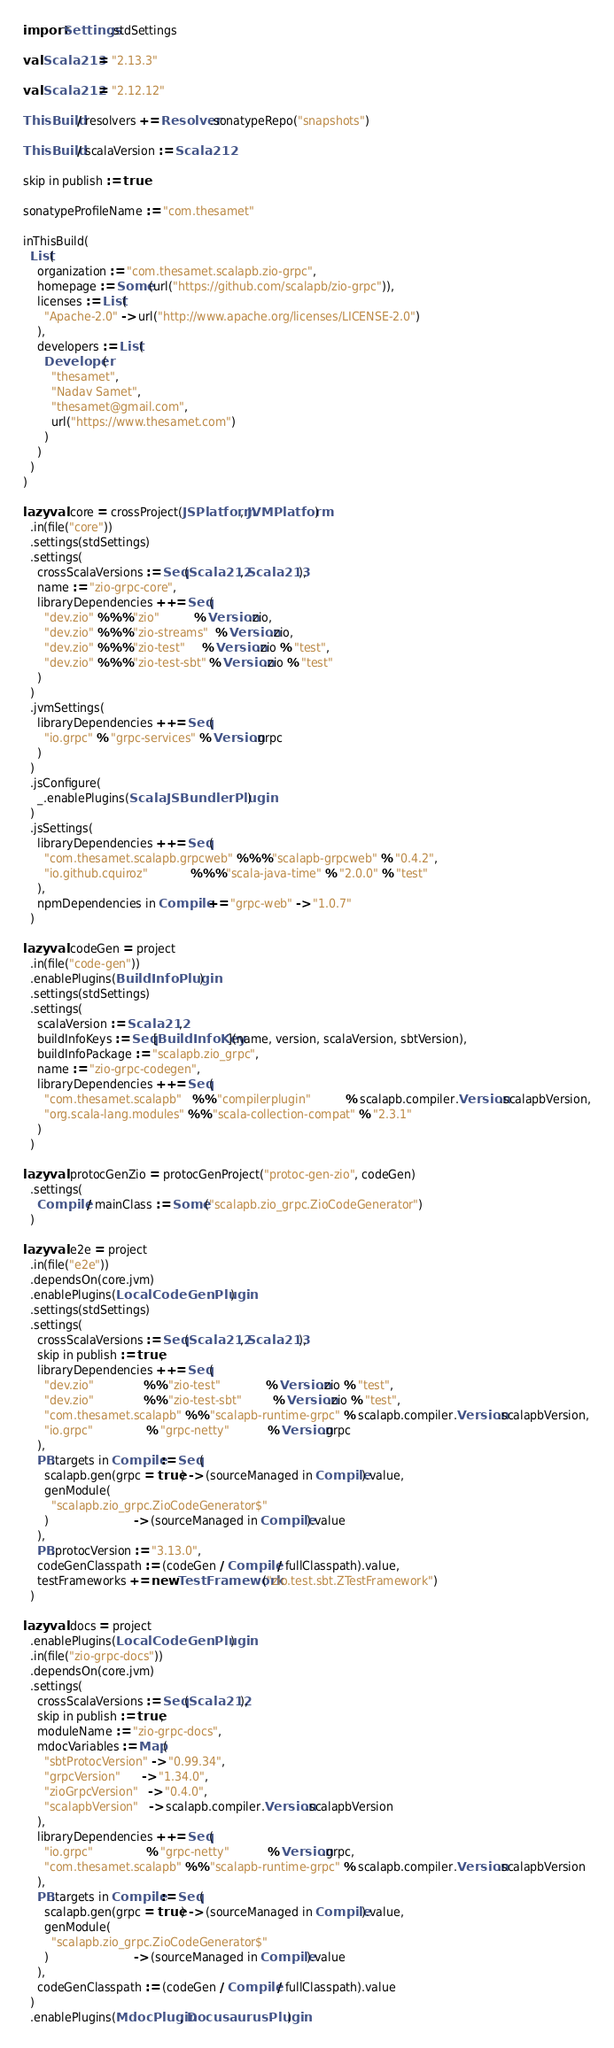Convert code to text. <code><loc_0><loc_0><loc_500><loc_500><_Scala_>import Settings.stdSettings

val Scala213 = "2.13.3"

val Scala212 = "2.12.12"

ThisBuild / resolvers += Resolver.sonatypeRepo("snapshots")

ThisBuild / scalaVersion := Scala212

skip in publish := true

sonatypeProfileName := "com.thesamet"

inThisBuild(
  List(
    organization := "com.thesamet.scalapb.zio-grpc",
    homepage := Some(url("https://github.com/scalapb/zio-grpc")),
    licenses := List(
      "Apache-2.0" -> url("http://www.apache.org/licenses/LICENSE-2.0")
    ),
    developers := List(
      Developer(
        "thesamet",
        "Nadav Samet",
        "thesamet@gmail.com",
        url("https://www.thesamet.com")
      )
    )
  )
)

lazy val core = crossProject(JSPlatform, JVMPlatform)
  .in(file("core"))
  .settings(stdSettings)
  .settings(
    crossScalaVersions := Seq(Scala212, Scala213),
    name := "zio-grpc-core",
    libraryDependencies ++= Seq(
      "dev.zio" %%% "zio"          % Version.zio,
      "dev.zio" %%% "zio-streams"  % Version.zio,
      "dev.zio" %%% "zio-test"     % Version.zio % "test",
      "dev.zio" %%% "zio-test-sbt" % Version.zio % "test"
    )
  )
  .jvmSettings(
    libraryDependencies ++= Seq(
      "io.grpc" % "grpc-services" % Version.grpc
    )
  )
  .jsConfigure(
    _.enablePlugins(ScalaJSBundlerPlugin)
  )
  .jsSettings(
    libraryDependencies ++= Seq(
      "com.thesamet.scalapb.grpcweb" %%% "scalapb-grpcweb" % "0.4.2",
      "io.github.cquiroz"            %%% "scala-java-time" % "2.0.0" % "test"
    ),
    npmDependencies in Compile += "grpc-web" -> "1.0.7"
  )

lazy val codeGen = project
  .in(file("code-gen"))
  .enablePlugins(BuildInfoPlugin)
  .settings(stdSettings)
  .settings(
    scalaVersion := Scala212,
    buildInfoKeys := Seq[BuildInfoKey](name, version, scalaVersion, sbtVersion),
    buildInfoPackage := "scalapb.zio_grpc",
    name := "zio-grpc-codegen",
    libraryDependencies ++= Seq(
      "com.thesamet.scalapb"   %% "compilerplugin"          % scalapb.compiler.Version.scalapbVersion,
      "org.scala-lang.modules" %% "scala-collection-compat" % "2.3.1"
    )
  )

lazy val protocGenZio = protocGenProject("protoc-gen-zio", codeGen)
  .settings(
    Compile / mainClass := Some("scalapb.zio_grpc.ZioCodeGenerator")
  )

lazy val e2e = project
  .in(file("e2e"))
  .dependsOn(core.jvm)
  .enablePlugins(LocalCodeGenPlugin)
  .settings(stdSettings)
  .settings(
    crossScalaVersions := Seq(Scala212, Scala213),
    skip in publish := true,
    libraryDependencies ++= Seq(
      "dev.zio"              %% "zio-test"             % Version.zio % "test",
      "dev.zio"              %% "zio-test-sbt"         % Version.zio % "test",
      "com.thesamet.scalapb" %% "scalapb-runtime-grpc" % scalapb.compiler.Version.scalapbVersion,
      "io.grpc"               % "grpc-netty"           % Version.grpc
    ),
    PB.targets in Compile := Seq(
      scalapb.gen(grpc = true) -> (sourceManaged in Compile).value,
      genModule(
        "scalapb.zio_grpc.ZioCodeGenerator$"
      )                        -> (sourceManaged in Compile).value
    ),
    PB.protocVersion := "3.13.0",
    codeGenClasspath := (codeGen / Compile / fullClasspath).value,
    testFrameworks += new TestFramework("zio.test.sbt.ZTestFramework")
  )

lazy val docs = project
  .enablePlugins(LocalCodeGenPlugin)
  .in(file("zio-grpc-docs"))
  .dependsOn(core.jvm)
  .settings(
    crossScalaVersions := Seq(Scala212),
    skip in publish := true,
    moduleName := "zio-grpc-docs",
    mdocVariables := Map(
      "sbtProtocVersion" -> "0.99.34",
      "grpcVersion"      -> "1.34.0",
      "zioGrpcVersion"   -> "0.4.0",
      "scalapbVersion"   -> scalapb.compiler.Version.scalapbVersion
    ),
    libraryDependencies ++= Seq(
      "io.grpc"               % "grpc-netty"           % Version.grpc,
      "com.thesamet.scalapb" %% "scalapb-runtime-grpc" % scalapb.compiler.Version.scalapbVersion
    ),
    PB.targets in Compile := Seq(
      scalapb.gen(grpc = true) -> (sourceManaged in Compile).value,
      genModule(
        "scalapb.zio_grpc.ZioCodeGenerator$"
      )                        -> (sourceManaged in Compile).value
    ),
    codeGenClasspath := (codeGen / Compile / fullClasspath).value
  )
  .enablePlugins(MdocPlugin, DocusaurusPlugin)
</code> 